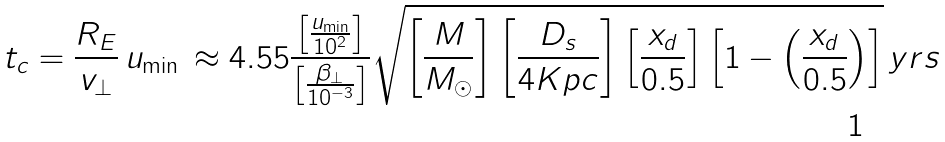<formula> <loc_0><loc_0><loc_500><loc_500>t _ { c } = \frac { R _ { E } } { v _ { \perp } } \, u _ { \min } \, \approx 4 . 5 5 \frac { \left [ \frac { u _ { \min } } { 1 0 ^ { 2 } } \right ] } { \left [ \frac { \beta _ { \perp } } { 1 0 ^ { - 3 } } \right ] } \sqrt { \left [ \frac { M } { M _ { \odot } } \right ] \left [ \frac { D _ { s } } { 4 K p c } \right ] \left [ \frac { x _ { d } } { 0 . 5 } \right ] \left [ 1 - \left ( \frac { x _ { d } } { 0 . 5 } \right ) \right ] } \, y r s</formula> 